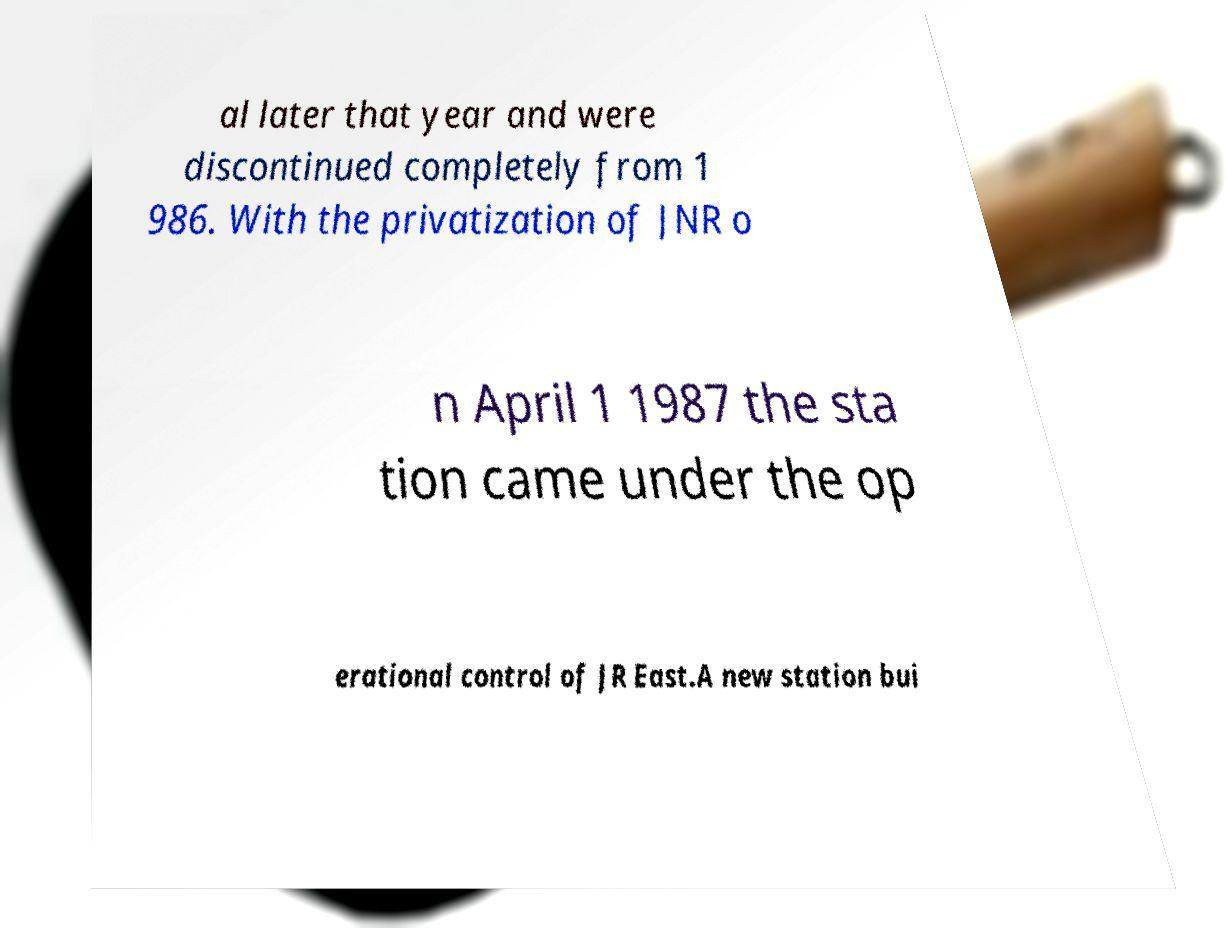Please read and relay the text visible in this image. What does it say? al later that year and were discontinued completely from 1 986. With the privatization of JNR o n April 1 1987 the sta tion came under the op erational control of JR East.A new station bui 